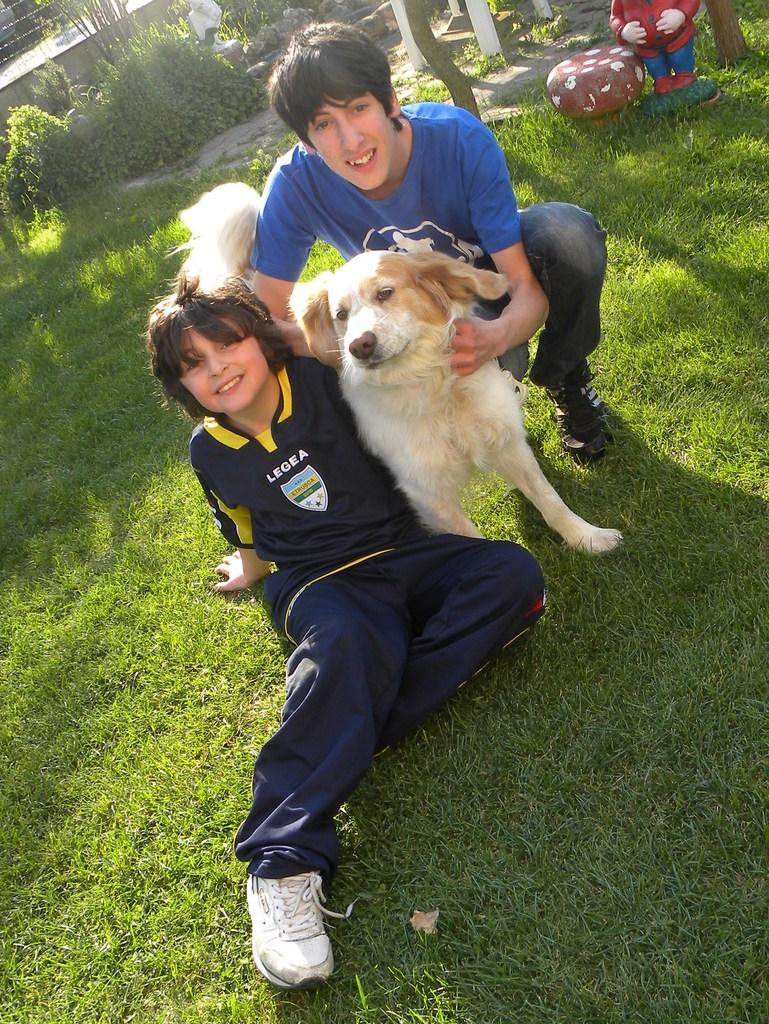How many people are in the image? There are two persons in the image. What other living creature is present in the image? There is a dog in the image. What type of ground surface is visible at the bottom of the image? Green grass is visible at the bottom of the image. What can be seen in the background of the image? There is a doll and plants present in the background of the image. What type of parcel is being delivered to the daughter in the image? There is no parcel or daughter present in the image. What kind of feast is being prepared by the persons in the image? There is no feast preparation visible in the image; the focus is on the two persons, a dog, and the background elements. 